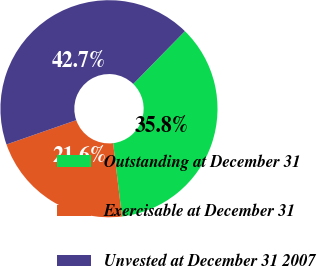<chart> <loc_0><loc_0><loc_500><loc_500><pie_chart><fcel>Outstanding at December 31<fcel>Exercisable at December 31<fcel>Unvested at December 31 2007<nl><fcel>35.76%<fcel>21.57%<fcel>42.67%<nl></chart> 